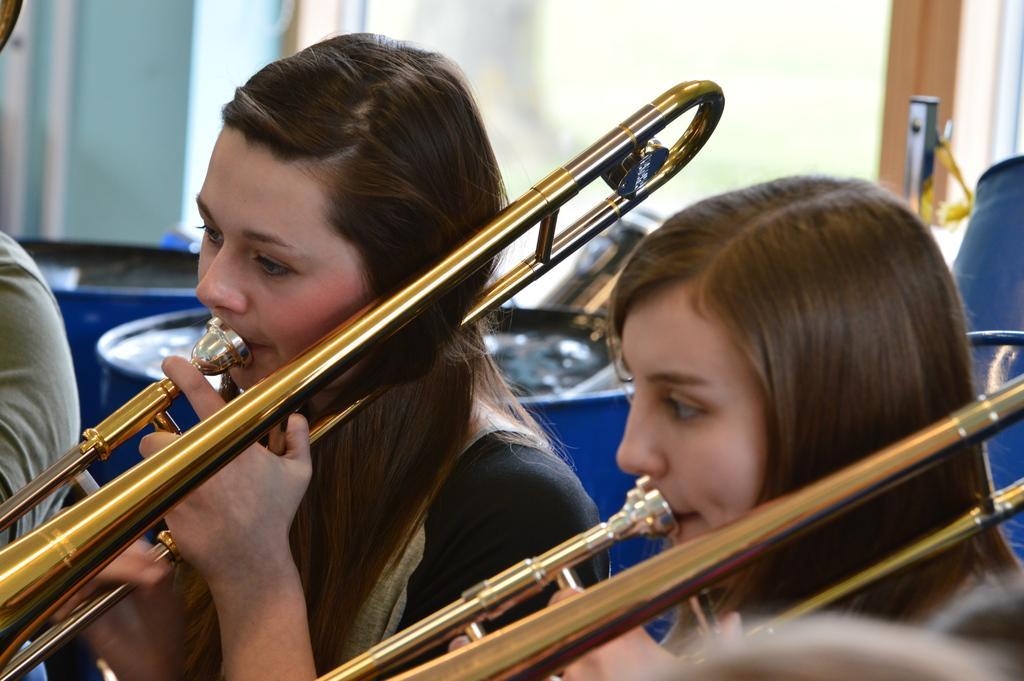Could you give a brief overview of what you see in this image? In this picture there are two women who are playing flute. Beside them I can see the blue chair. At the top there is a door. On the left I can see the person's hand who is sitting on the chair. 